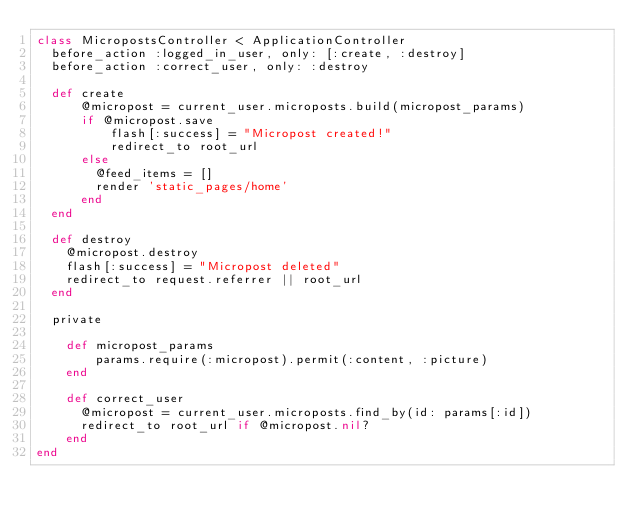<code> <loc_0><loc_0><loc_500><loc_500><_Ruby_>class MicropostsController < ApplicationController
	before_action :logged_in_user, only: [:create, :destroy]
  before_action :correct_user, only: :destroy

	def create
    	@micropost = current_user.microposts.build(micropost_params)
    	if @micropost.save
      		flash[:success] = "Micropost created!"
      		redirect_to root_url
   		else
        @feed_items = []
      	render 'static_pages/home'
    	end
 	end

  def destroy
    @micropost.destroy
    flash[:success] = "Micropost deleted"
    redirect_to request.referrer || root_url
  end

  private

    def micropost_params
    		params.require(:micropost).permit(:content, :picture)
    end
    
    def correct_user
      @micropost = current_user.microposts.find_by(id: params[:id])
      redirect_to root_url if @micropost.nil?
    end
end
</code> 